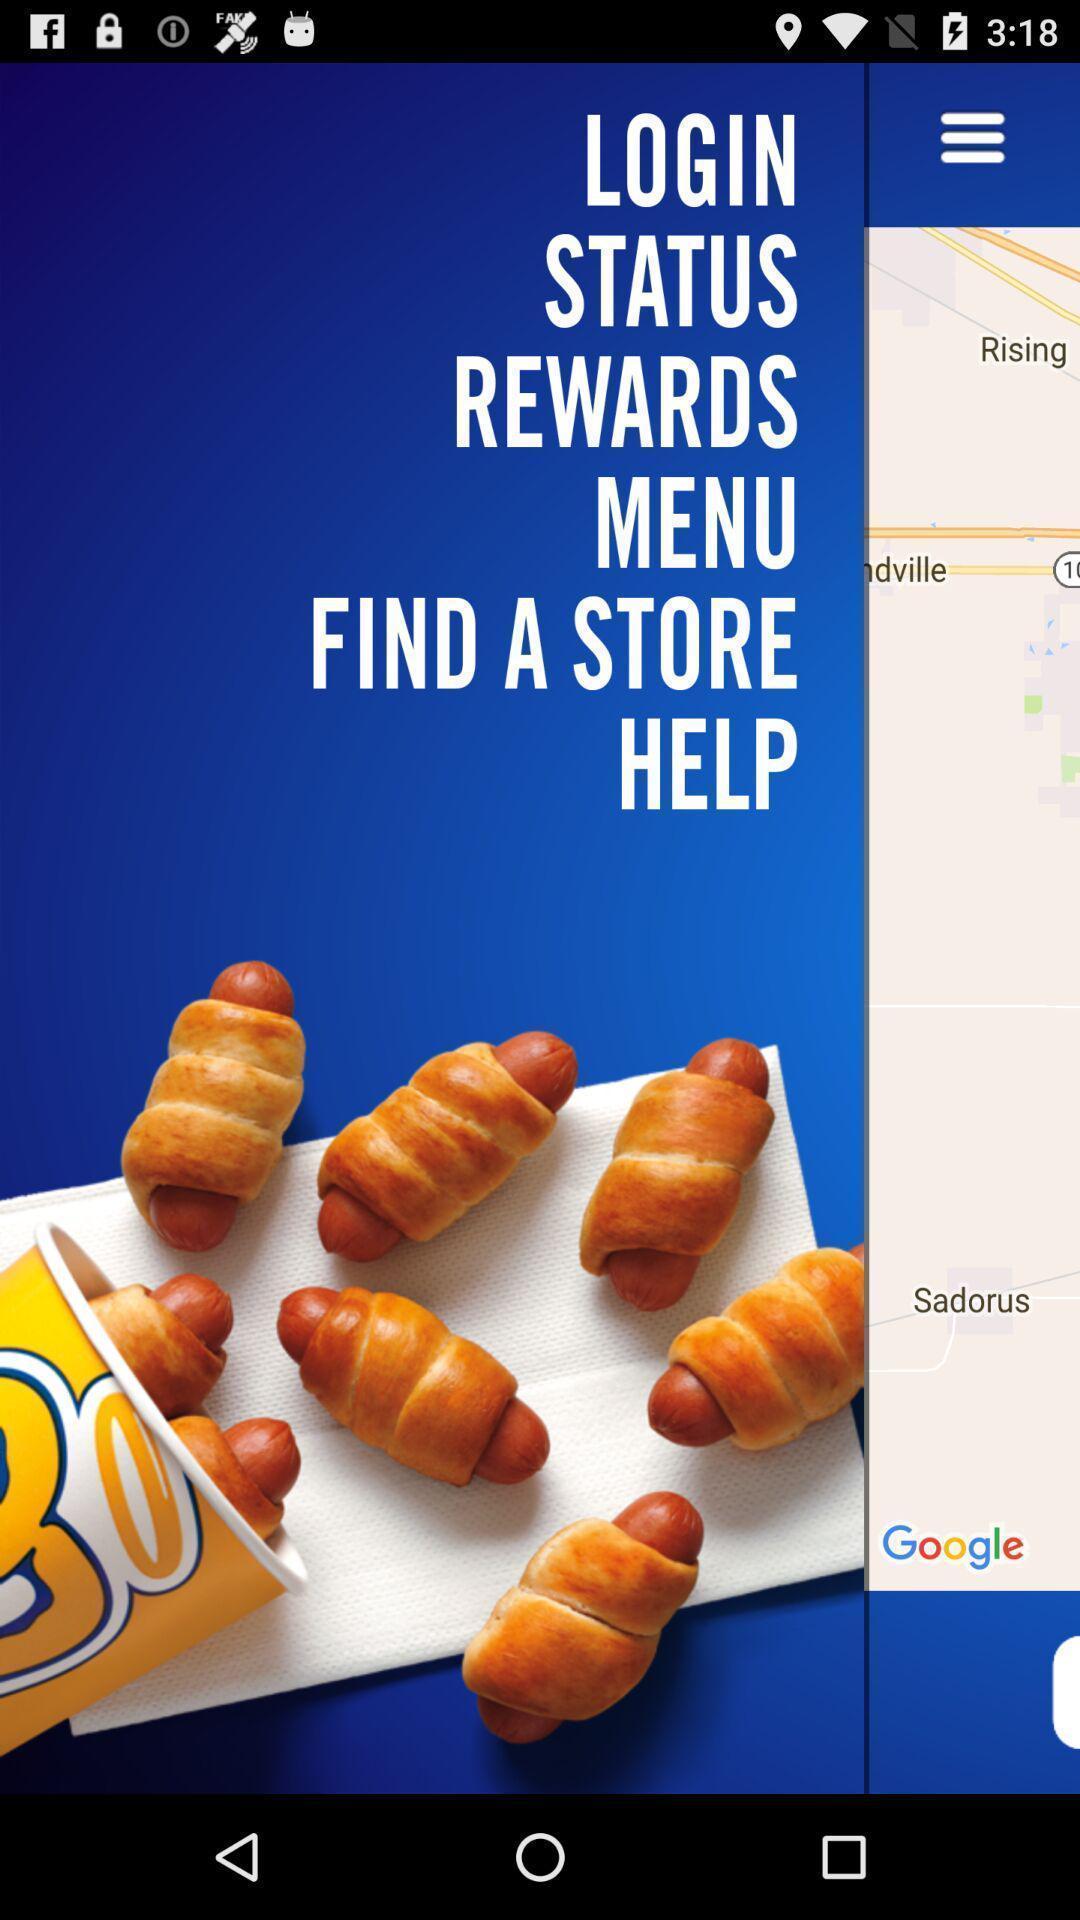Provide a textual representation of this image. Screen displaying page with options. 